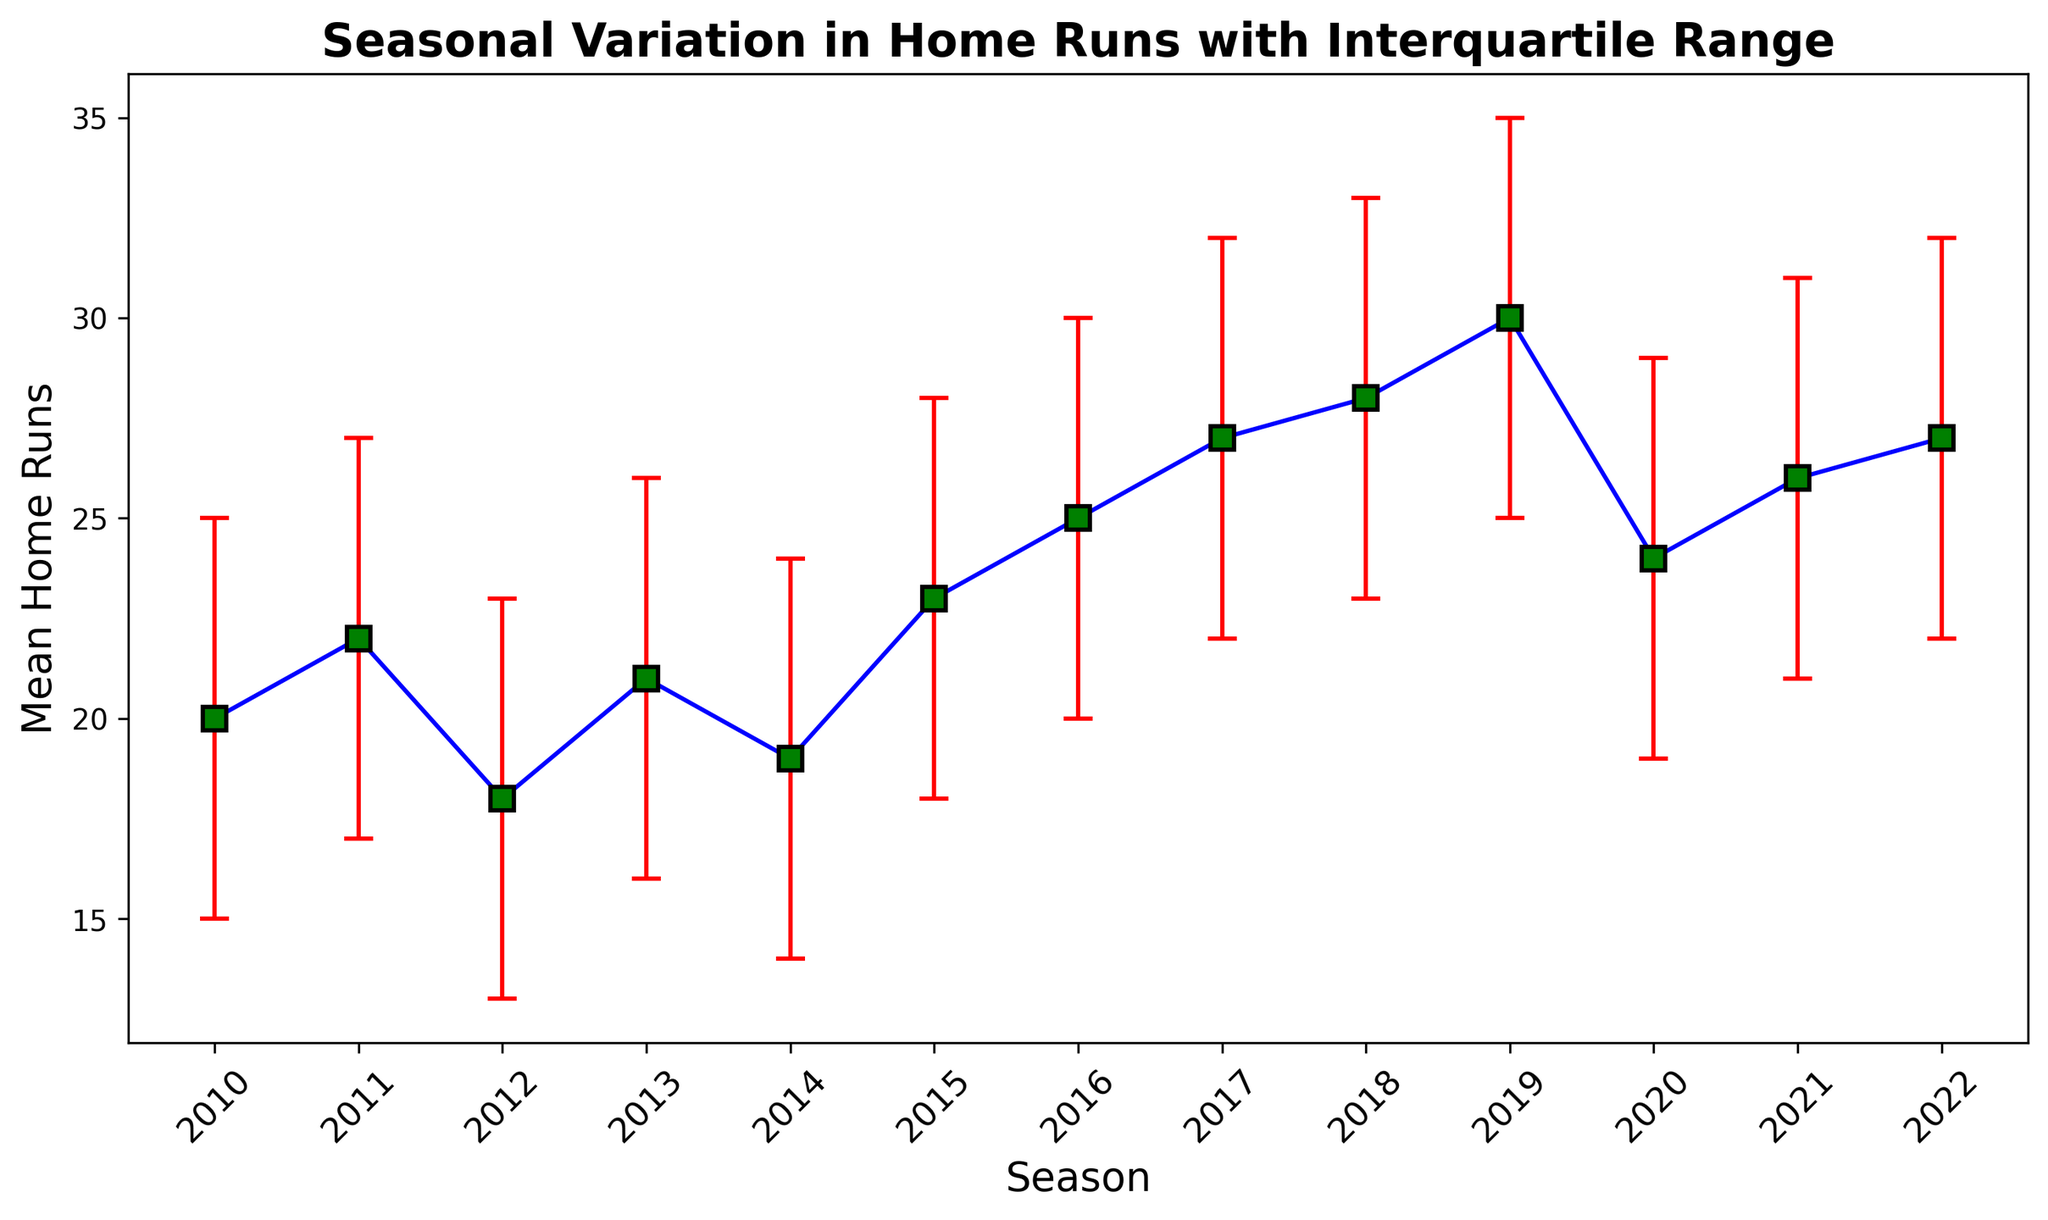What's the mean home runs in 2015? The chart shows that the mean home runs in 2015 are represented by the blue line and green markers. Looking at the blue line at 2015, the value is 23.
Answer: 23 Which season has the highest mean home runs? Comparing the mean home run values for all seasons, the highest point on the blue line and green markers occurs in 2019 with a mean of 30.
Answer: 2019 What's the range of the interquartile range (IQR) for the 2017 season? The IQR for 2017 is given as the difference between the upper quartile and the lower quartile. Here, the upper quartile is 32 and the lower quartile is 22, so the range is 32 - 22 = 10.
Answer: 10 How does the mean home runs in 2011 compare to 2020? For 2011, the mean home runs is 22, and for 2020, it's 24. Comparing these values, the mean home runs in 2020 (24) is higher than in 2011 (22).
Answer: 24 is higher than 22 What season shows the largest difference between its upper and lower IQR values? Comparing the difference between upper and lower IQR values across all seasons, the largest difference is in 2019 (35-25=10).
Answer: 2019 Which year shows the lowest mean home runs, and what is its value? Analyzing the blue line and green markers, the lowest value occurs in 2012 with a mean of 18.
Answer: 2012, 18 What is the mean increase in home runs from 2016 to 2017? The mean home runs in 2016 is 25, and in 2017 it is 27. The mean increase is 27-25 = 2.
Answer: 2 How does the IQR in 2021 compare to 2022? In 2021, the IQR is from 21 to 31 which is 31 - 21 = 10, while in 2022 it is from 22 to 32 which is 32 - 22 = 10. The IQR is the same for both years.
Answer: same What is the average mean home runs over the seasons from 2010 to 2012? Mean home runs for 2010, 2011, and 2012 are 20, 22, and 18 respectively. The average is (20 + 22 + 18) / 3 = 20.
Answer: 20 